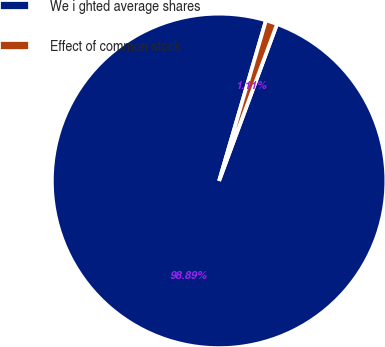Convert chart. <chart><loc_0><loc_0><loc_500><loc_500><pie_chart><fcel>We i ghted average shares<fcel>Effect of common stock<nl><fcel>98.89%<fcel>1.11%<nl></chart> 